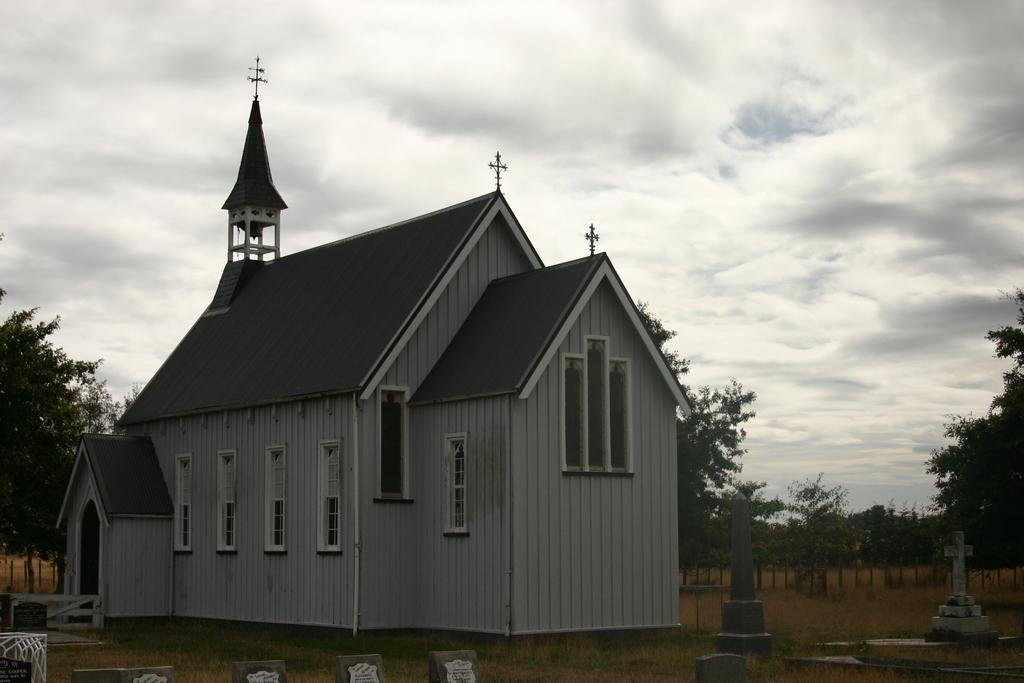In one or two sentences, can you explain what this image depicts? In the picture we can see a church building with windows and door and near to it, we can see some graves on the surface and in the background, we can see some plants, trees and sky with clouds and on the church we can see a cross symbol on the top of it. 